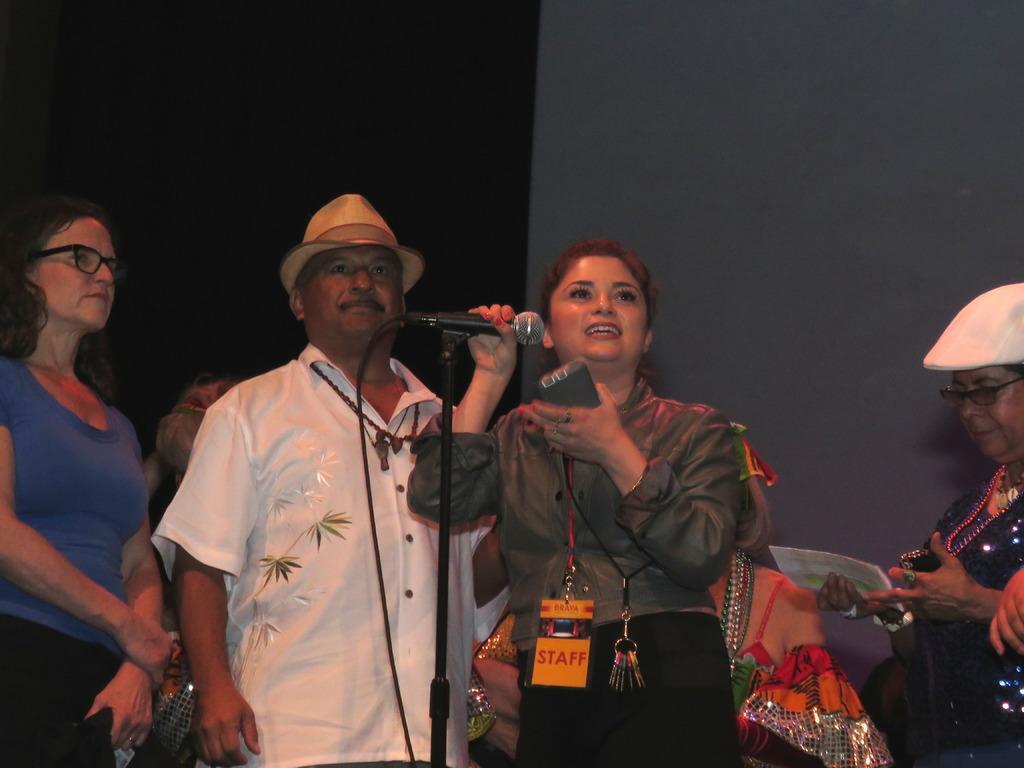Can you describe this image briefly? In this image, There are some people standing and in the middle there is a girl standing and she is holding a microphone which is in black color she is holding a mobile in her left hand, In the background there is a white color wall. 